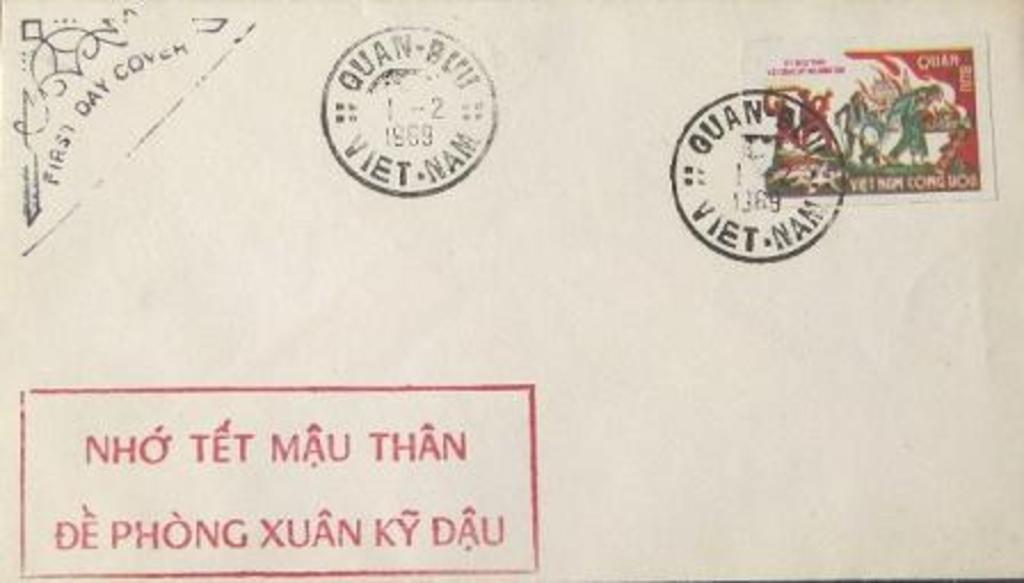<image>
Summarize the visual content of the image. an envelope that has a stamp that says 'vietnam' on it 